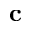Convert formula to latex. <formula><loc_0><loc_0><loc_500><loc_500>c</formula> 